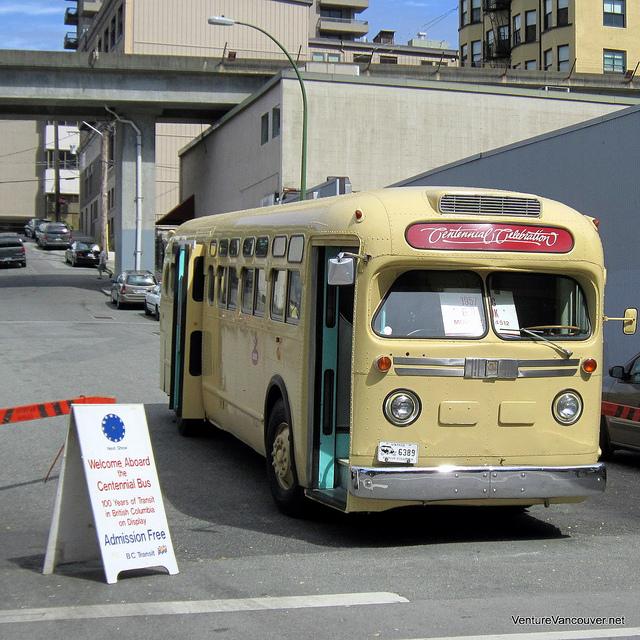How much is admission?
Short answer required. Free. What color is the bus?
Quick response, please. Yellow. Is this a modern bus?
Write a very short answer. No. 